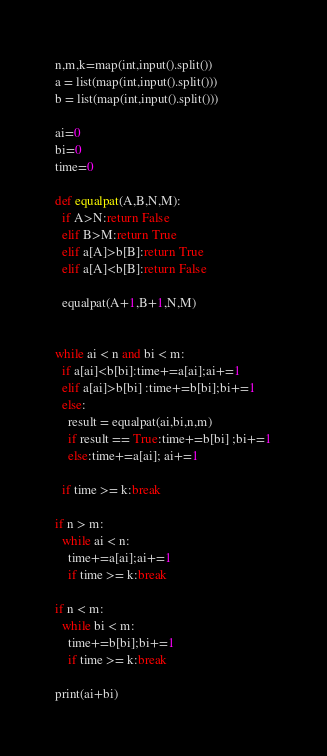<code> <loc_0><loc_0><loc_500><loc_500><_Python_>n,m,k=map(int,input().split())
a = list(map(int,input().split()))
b = list(map(int,input().split()))

ai=0
bi=0
time=0

def equalpat(A,B,N,M):
  if A>N:return False
  elif B>M:return True
  elif a[A]>b[B]:return True
  elif a[A]<b[B]:return False
  
  equalpat(A+1,B+1,N,M)


while ai < n and bi < m:
  if a[ai]<b[bi]:time+=a[ai];ai+=1
  elif a[ai]>b[bi] :time+=b[bi];bi+=1
  else:
    result = equalpat(ai,bi,n,m)
    if result == True:time+=b[bi] ;bi+=1
    else:time+=a[ai]; ai+=1

  if time >= k:break
    
if n > m:
  while ai < n:
    time+=a[ai];ai+=1
    if time >= k:break

if n < m:
  while bi < m:
    time+=b[bi];bi+=1
    if time >= k:break
      
print(ai+bi)</code> 